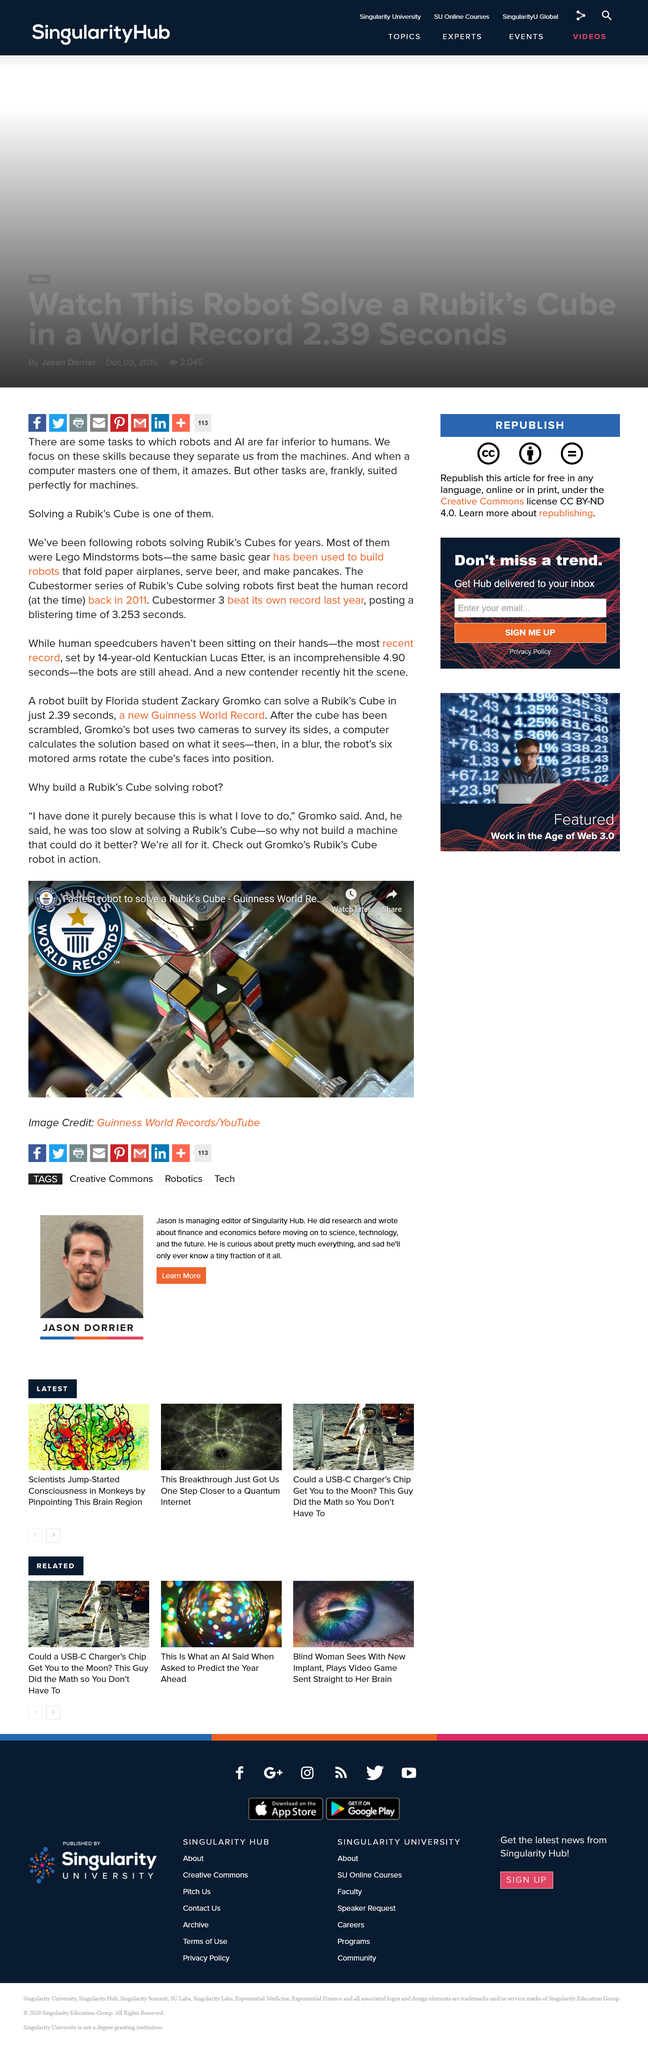Point out several critical features in this image. Gromko was unable to solve a Rubik's cube quickly, making him one of the slowest individuals in this task. Gromko's reason for building a Rubik's cube solving robot is purely out of love for the task. The Rubik's cube was created by Gromko to solve a machine. 